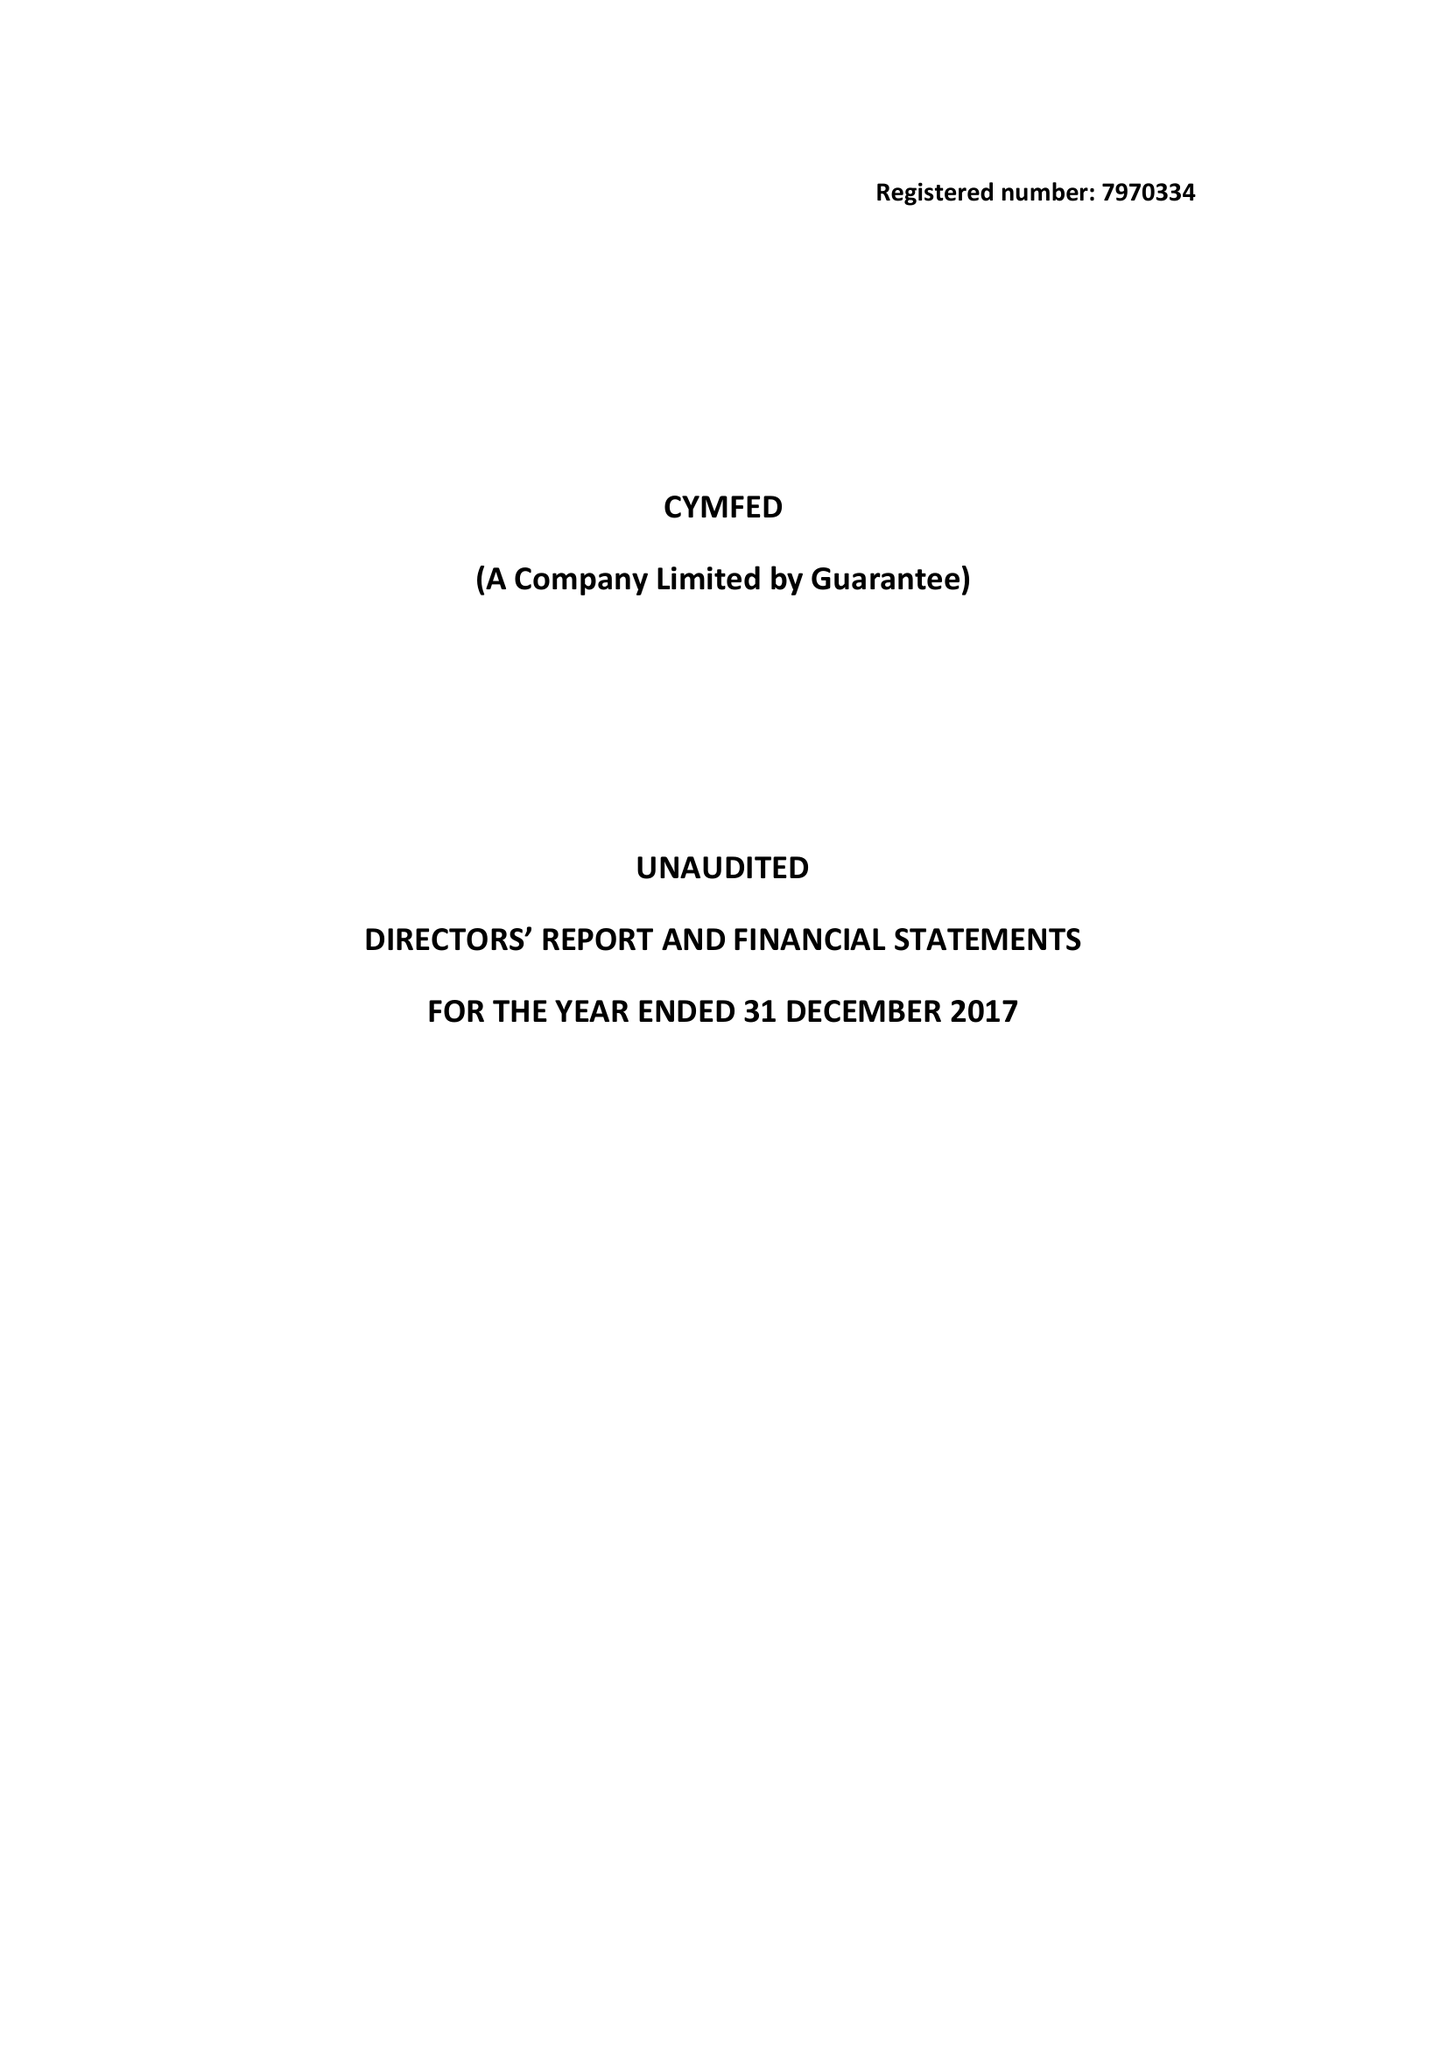What is the value for the income_annually_in_british_pounds?
Answer the question using a single word or phrase. 183129.00 